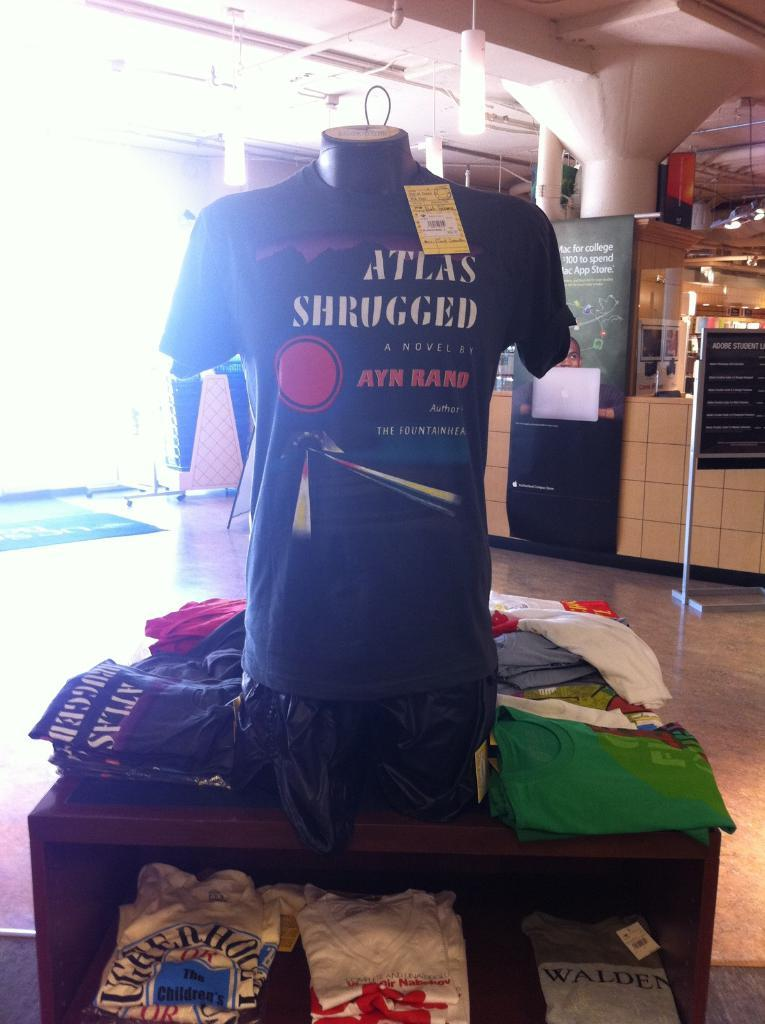Provide a one-sentence caption for the provided image. A t-shirt for Ayn Rand's Atlas Shrugged is displayed on a mannequin chest. 